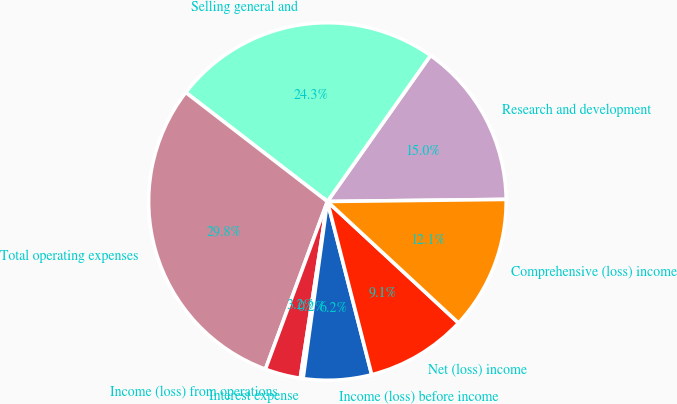<chart> <loc_0><loc_0><loc_500><loc_500><pie_chart><fcel>Research and development<fcel>Selling general and<fcel>Total operating expenses<fcel>Income (loss) from operations<fcel>Interest expense<fcel>Income (loss) before income<fcel>Net (loss) income<fcel>Comprehensive (loss) income<nl><fcel>15.03%<fcel>24.34%<fcel>29.81%<fcel>3.21%<fcel>0.25%<fcel>6.16%<fcel>9.12%<fcel>12.08%<nl></chart> 